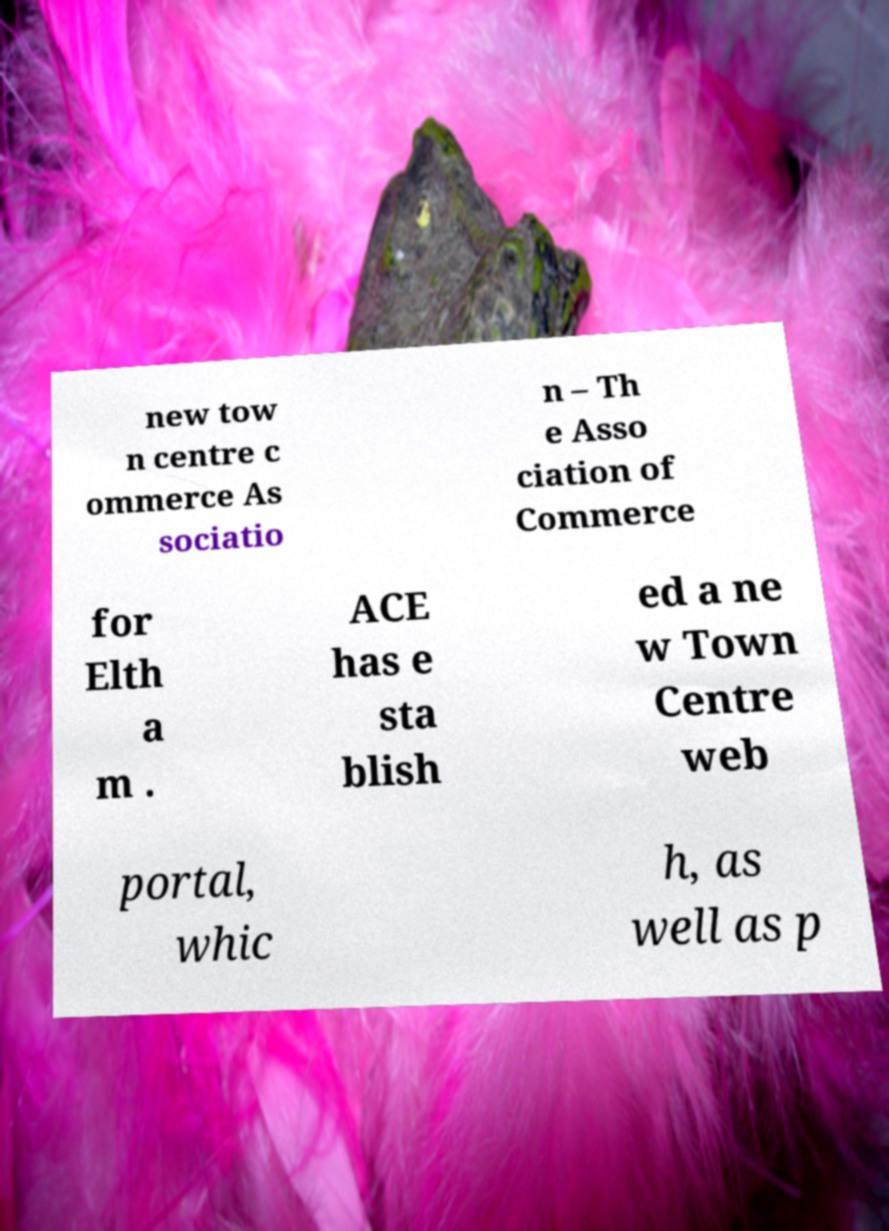Please identify and transcribe the text found in this image. new tow n centre c ommerce As sociatio n – Th e Asso ciation of Commerce for Elth a m . ACE has e sta blish ed a ne w Town Centre web portal, whic h, as well as p 